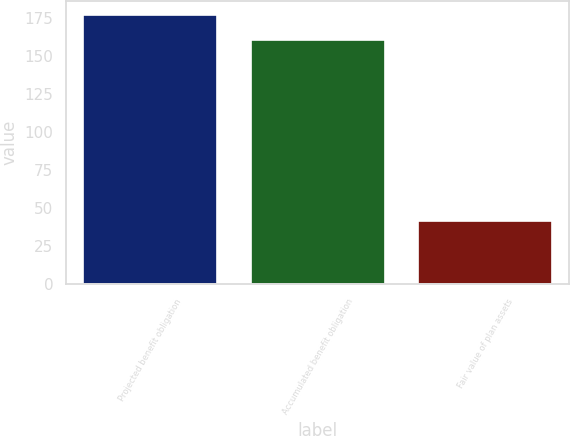Convert chart to OTSL. <chart><loc_0><loc_0><loc_500><loc_500><bar_chart><fcel>Projected benefit obligation<fcel>Accumulated benefit obligation<fcel>Fair value of plan assets<nl><fcel>177.4<fcel>160.6<fcel>41.3<nl></chart> 